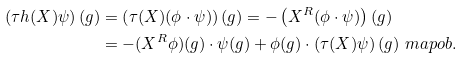<formula> <loc_0><loc_0><loc_500><loc_500>\left ( \tau h ( X ) \psi \right ) ( g ) & = \left ( \tau ( X ) ( \phi \cdot \psi ) \right ) ( g ) = - \left ( X ^ { R } ( \phi \cdot \psi ) \right ) ( g ) \\ & = - ( X ^ { R } \phi ) ( g ) \cdot \psi ( g ) + \phi ( g ) \cdot \left ( \tau ( X ) \psi \right ) ( g ) \ m a p o b .</formula> 